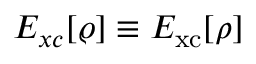<formula> <loc_0><loc_0><loc_500><loc_500>E _ { x c } [ \varrho ] \equiv E _ { x c } [ \rho ]</formula> 